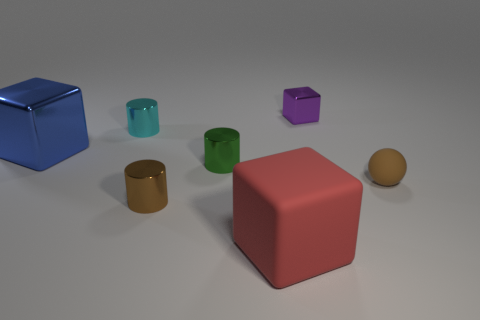Subtract all green metal cylinders. How many cylinders are left? 2 Subtract all brown cylinders. How many cylinders are left? 2 Add 2 small cyan rubber balls. How many objects exist? 9 Subtract 1 spheres. How many spheres are left? 0 Subtract all blocks. How many objects are left? 4 Subtract all green blocks. How many brown cylinders are left? 1 Subtract all yellow cylinders. Subtract all brown balls. How many cylinders are left? 3 Subtract all small green metal cylinders. Subtract all small green objects. How many objects are left? 5 Add 1 large red blocks. How many large red blocks are left? 2 Add 6 small cubes. How many small cubes exist? 7 